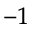Convert formula to latex. <formula><loc_0><loc_0><loc_500><loc_500>^ { - 1 }</formula> 